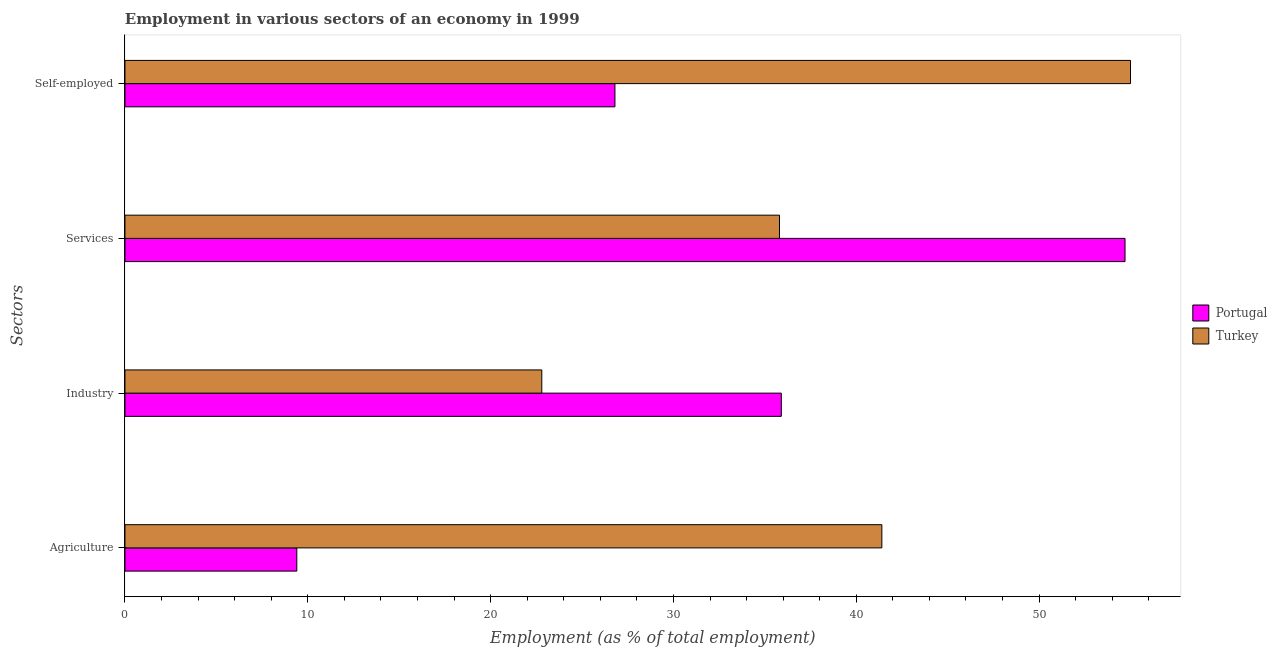Are the number of bars on each tick of the Y-axis equal?
Your response must be concise. Yes. What is the label of the 3rd group of bars from the top?
Keep it short and to the point. Industry. What is the percentage of workers in services in Portugal?
Give a very brief answer. 54.7. Across all countries, what is the maximum percentage of workers in industry?
Keep it short and to the point. 35.9. Across all countries, what is the minimum percentage of self employed workers?
Your answer should be very brief. 26.8. In which country was the percentage of self employed workers minimum?
Provide a short and direct response. Portugal. What is the total percentage of self employed workers in the graph?
Provide a succinct answer. 81.8. What is the difference between the percentage of workers in industry in Turkey and that in Portugal?
Keep it short and to the point. -13.1. What is the difference between the percentage of workers in services in Turkey and the percentage of self employed workers in Portugal?
Keep it short and to the point. 9. What is the average percentage of self employed workers per country?
Offer a very short reply. 40.9. What is the difference between the percentage of workers in services and percentage of self employed workers in Portugal?
Your answer should be very brief. 27.9. In how many countries, is the percentage of workers in agriculture greater than 16 %?
Your response must be concise. 1. What is the ratio of the percentage of workers in agriculture in Turkey to that in Portugal?
Your response must be concise. 4.4. Is the percentage of workers in agriculture in Portugal less than that in Turkey?
Make the answer very short. Yes. What is the difference between the highest and the second highest percentage of workers in agriculture?
Your response must be concise. 32. What is the difference between the highest and the lowest percentage of workers in agriculture?
Offer a terse response. 32. Is it the case that in every country, the sum of the percentage of workers in industry and percentage of workers in services is greater than the sum of percentage of self employed workers and percentage of workers in agriculture?
Ensure brevity in your answer.  No. What does the 1st bar from the top in Self-employed represents?
Your answer should be very brief. Turkey. What does the 1st bar from the bottom in Services represents?
Provide a short and direct response. Portugal. Is it the case that in every country, the sum of the percentage of workers in agriculture and percentage of workers in industry is greater than the percentage of workers in services?
Ensure brevity in your answer.  No. How many bars are there?
Offer a terse response. 8. Are all the bars in the graph horizontal?
Make the answer very short. Yes. How many countries are there in the graph?
Give a very brief answer. 2. What is the difference between two consecutive major ticks on the X-axis?
Provide a succinct answer. 10. Are the values on the major ticks of X-axis written in scientific E-notation?
Ensure brevity in your answer.  No. Does the graph contain grids?
Make the answer very short. No. How many legend labels are there?
Your response must be concise. 2. What is the title of the graph?
Give a very brief answer. Employment in various sectors of an economy in 1999. What is the label or title of the X-axis?
Keep it short and to the point. Employment (as % of total employment). What is the label or title of the Y-axis?
Offer a terse response. Sectors. What is the Employment (as % of total employment) in Portugal in Agriculture?
Ensure brevity in your answer.  9.4. What is the Employment (as % of total employment) of Turkey in Agriculture?
Give a very brief answer. 41.4. What is the Employment (as % of total employment) of Portugal in Industry?
Give a very brief answer. 35.9. What is the Employment (as % of total employment) of Turkey in Industry?
Provide a short and direct response. 22.8. What is the Employment (as % of total employment) in Portugal in Services?
Keep it short and to the point. 54.7. What is the Employment (as % of total employment) in Turkey in Services?
Provide a short and direct response. 35.8. What is the Employment (as % of total employment) in Portugal in Self-employed?
Your response must be concise. 26.8. What is the Employment (as % of total employment) of Turkey in Self-employed?
Keep it short and to the point. 55. Across all Sectors, what is the maximum Employment (as % of total employment) of Portugal?
Your answer should be very brief. 54.7. Across all Sectors, what is the minimum Employment (as % of total employment) of Portugal?
Keep it short and to the point. 9.4. Across all Sectors, what is the minimum Employment (as % of total employment) in Turkey?
Keep it short and to the point. 22.8. What is the total Employment (as % of total employment) in Portugal in the graph?
Make the answer very short. 126.8. What is the total Employment (as % of total employment) in Turkey in the graph?
Your answer should be compact. 155. What is the difference between the Employment (as % of total employment) in Portugal in Agriculture and that in Industry?
Make the answer very short. -26.5. What is the difference between the Employment (as % of total employment) in Turkey in Agriculture and that in Industry?
Offer a terse response. 18.6. What is the difference between the Employment (as % of total employment) of Portugal in Agriculture and that in Services?
Provide a short and direct response. -45.3. What is the difference between the Employment (as % of total employment) in Portugal in Agriculture and that in Self-employed?
Provide a succinct answer. -17.4. What is the difference between the Employment (as % of total employment) in Turkey in Agriculture and that in Self-employed?
Make the answer very short. -13.6. What is the difference between the Employment (as % of total employment) of Portugal in Industry and that in Services?
Keep it short and to the point. -18.8. What is the difference between the Employment (as % of total employment) in Portugal in Industry and that in Self-employed?
Provide a short and direct response. 9.1. What is the difference between the Employment (as % of total employment) of Turkey in Industry and that in Self-employed?
Provide a short and direct response. -32.2. What is the difference between the Employment (as % of total employment) in Portugal in Services and that in Self-employed?
Provide a short and direct response. 27.9. What is the difference between the Employment (as % of total employment) of Turkey in Services and that in Self-employed?
Offer a very short reply. -19.2. What is the difference between the Employment (as % of total employment) in Portugal in Agriculture and the Employment (as % of total employment) in Turkey in Services?
Keep it short and to the point. -26.4. What is the difference between the Employment (as % of total employment) of Portugal in Agriculture and the Employment (as % of total employment) of Turkey in Self-employed?
Offer a very short reply. -45.6. What is the difference between the Employment (as % of total employment) of Portugal in Industry and the Employment (as % of total employment) of Turkey in Self-employed?
Your response must be concise. -19.1. What is the average Employment (as % of total employment) in Portugal per Sectors?
Provide a succinct answer. 31.7. What is the average Employment (as % of total employment) in Turkey per Sectors?
Keep it short and to the point. 38.75. What is the difference between the Employment (as % of total employment) in Portugal and Employment (as % of total employment) in Turkey in Agriculture?
Ensure brevity in your answer.  -32. What is the difference between the Employment (as % of total employment) in Portugal and Employment (as % of total employment) in Turkey in Services?
Ensure brevity in your answer.  18.9. What is the difference between the Employment (as % of total employment) of Portugal and Employment (as % of total employment) of Turkey in Self-employed?
Offer a terse response. -28.2. What is the ratio of the Employment (as % of total employment) in Portugal in Agriculture to that in Industry?
Give a very brief answer. 0.26. What is the ratio of the Employment (as % of total employment) in Turkey in Agriculture to that in Industry?
Keep it short and to the point. 1.82. What is the ratio of the Employment (as % of total employment) of Portugal in Agriculture to that in Services?
Your answer should be very brief. 0.17. What is the ratio of the Employment (as % of total employment) in Turkey in Agriculture to that in Services?
Provide a succinct answer. 1.16. What is the ratio of the Employment (as % of total employment) in Portugal in Agriculture to that in Self-employed?
Make the answer very short. 0.35. What is the ratio of the Employment (as % of total employment) of Turkey in Agriculture to that in Self-employed?
Provide a succinct answer. 0.75. What is the ratio of the Employment (as % of total employment) in Portugal in Industry to that in Services?
Your response must be concise. 0.66. What is the ratio of the Employment (as % of total employment) in Turkey in Industry to that in Services?
Your answer should be compact. 0.64. What is the ratio of the Employment (as % of total employment) in Portugal in Industry to that in Self-employed?
Offer a terse response. 1.34. What is the ratio of the Employment (as % of total employment) of Turkey in Industry to that in Self-employed?
Your answer should be compact. 0.41. What is the ratio of the Employment (as % of total employment) of Portugal in Services to that in Self-employed?
Offer a very short reply. 2.04. What is the ratio of the Employment (as % of total employment) in Turkey in Services to that in Self-employed?
Your answer should be compact. 0.65. What is the difference between the highest and the lowest Employment (as % of total employment) of Portugal?
Your answer should be very brief. 45.3. What is the difference between the highest and the lowest Employment (as % of total employment) of Turkey?
Your answer should be very brief. 32.2. 